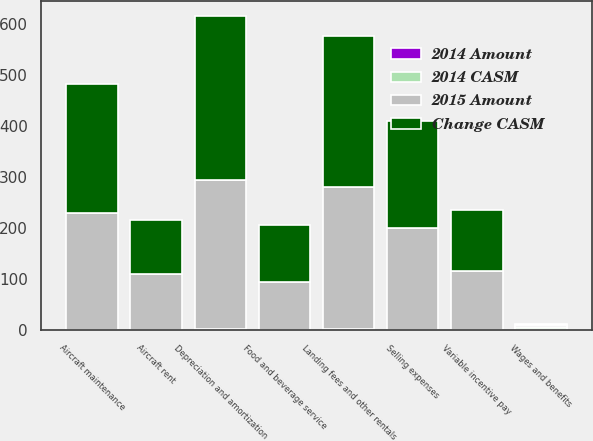<chart> <loc_0><loc_0><loc_500><loc_500><stacked_bar_chart><ecel><fcel>Wages and benefits<fcel>Variable incentive pay<fcel>Aircraft maintenance<fcel>Aircraft rent<fcel>Landing fees and other rentals<fcel>Selling expenses<fcel>Depreciation and amortization<fcel>Food and beverage service<nl><fcel>Change CASM<fcel>3.15<fcel>120<fcel>253<fcel>105<fcel>296<fcel>211<fcel>320<fcel>113<nl><fcel>2015 Amount<fcel>3.15<fcel>116<fcel>229<fcel>110<fcel>279<fcel>199<fcel>294<fcel>93<nl><fcel>2014 CASM<fcel>3.14<fcel>0.3<fcel>0.64<fcel>0.26<fcel>0.74<fcel>0.53<fcel>0.8<fcel>0.28<nl><fcel>2014 Amount<fcel>3.16<fcel>0.32<fcel>0.63<fcel>0.3<fcel>0.77<fcel>0.55<fcel>0.81<fcel>0.26<nl></chart> 